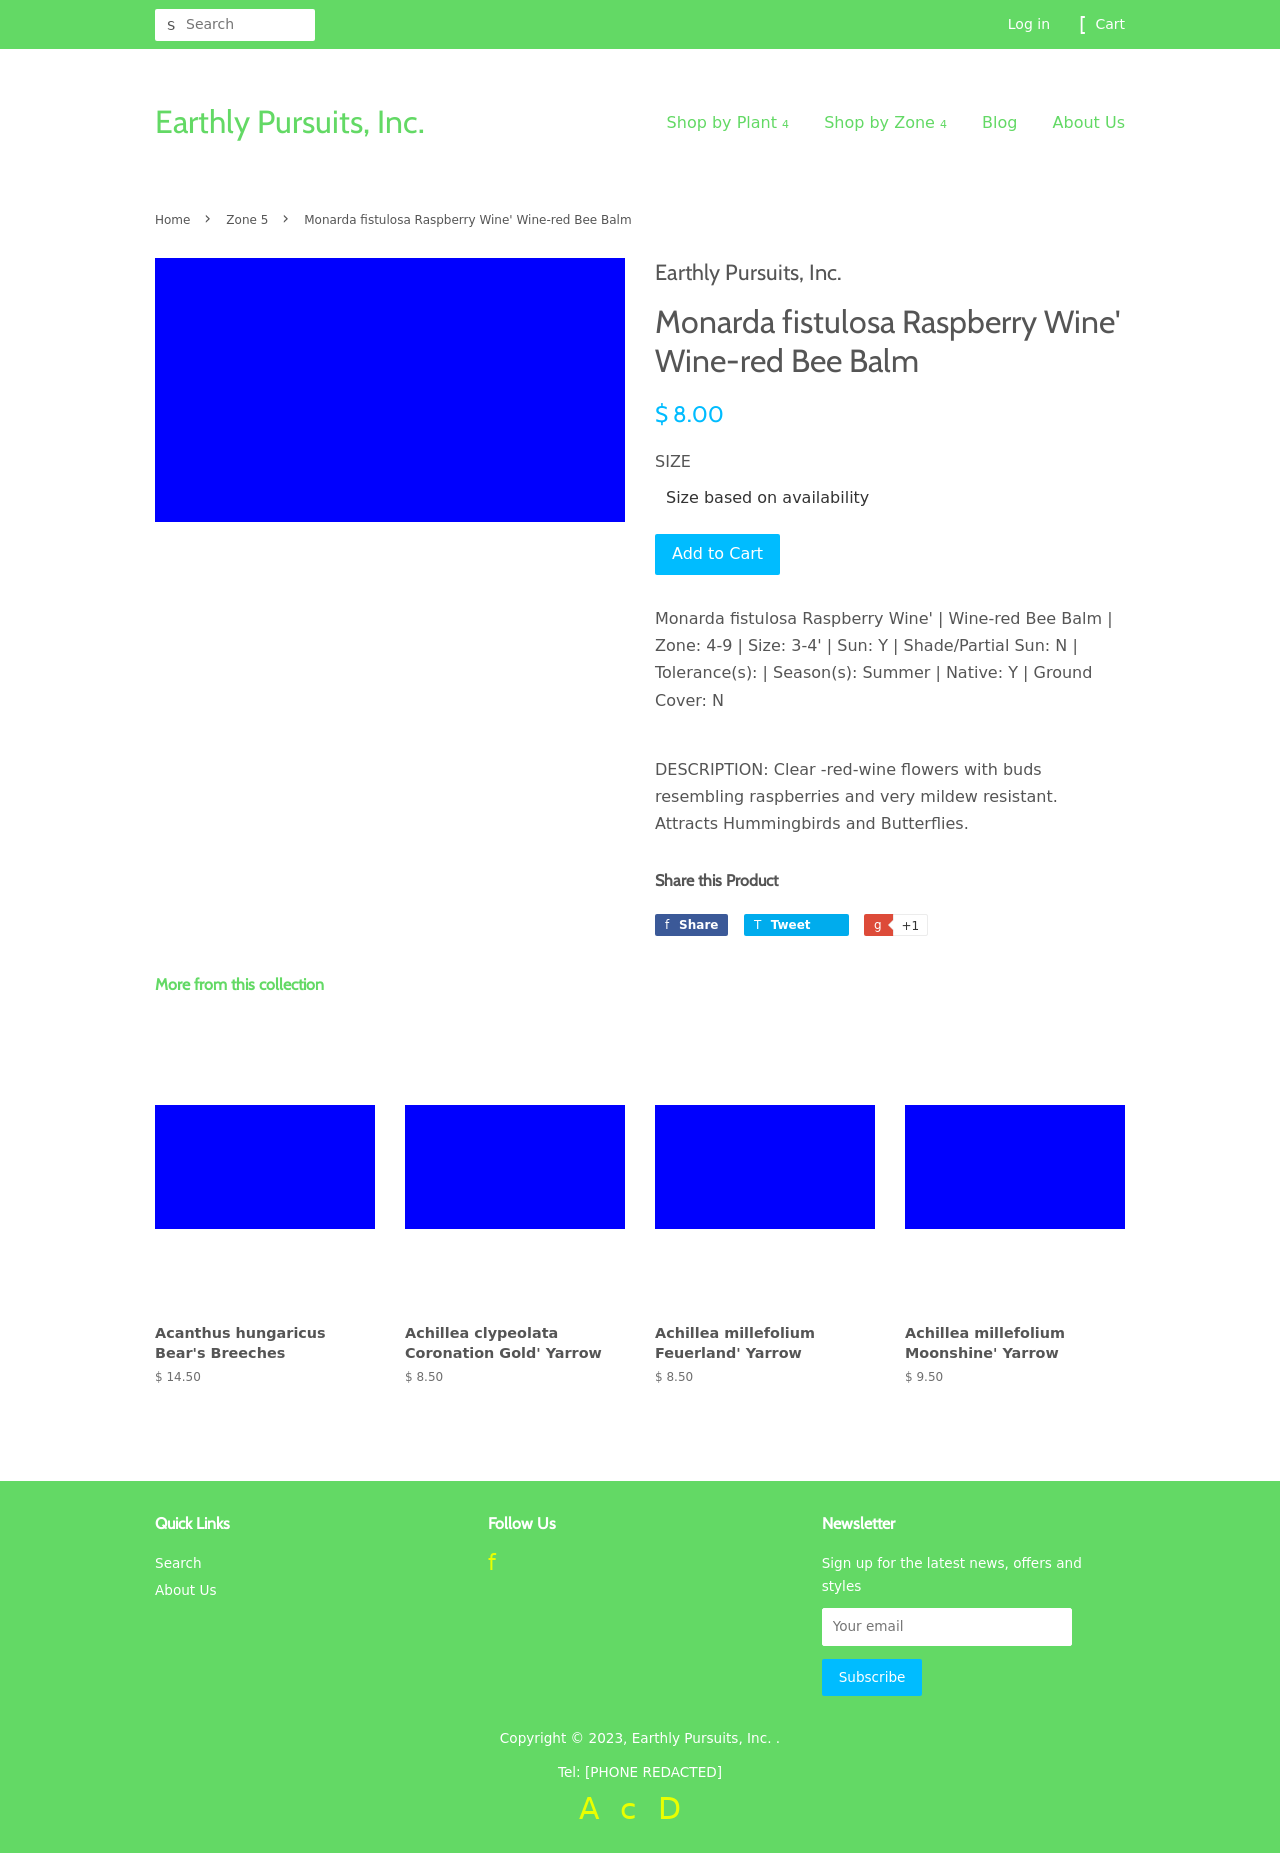What's the procedure for constructing this website from scratch with HTML? To build a website similar to the one in the image from scratch using HTML, start by setting up the basic structure with a <!DOCTYPE html> declaration, followed by the html element containing head and body sections. Within the head, specify your metadata and links to CSS for styling. In the body, structure your components using div tags for layout, such as headers, main sections, and footers. Include nav tags for navigation linked to your product sections, and use form tags within your product details for actions like 'Add to Cart'. Lastly, ensure your website is responsive by including appropriate meta tags for viewport settings and linking to responsive CSS frameworks or writing your own media queries. 